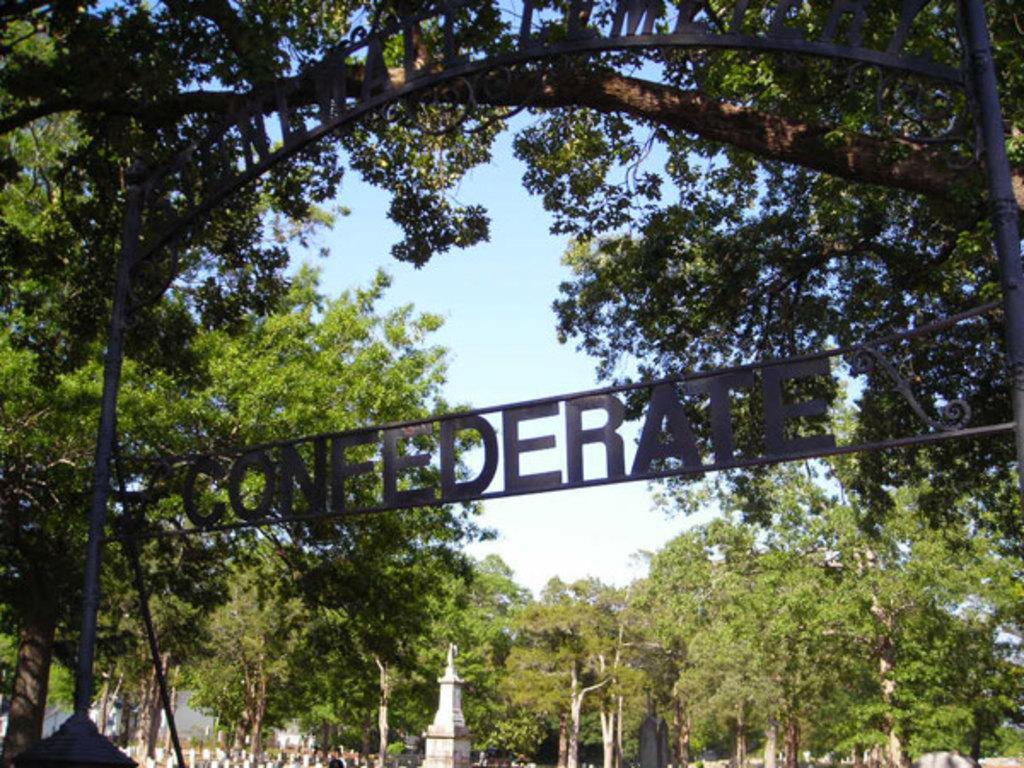Could you give a brief overview of what you see in this image? In this image we can see the boards with some text, there are some trees, poles, towers and the wall, in the background we can see the sky. 